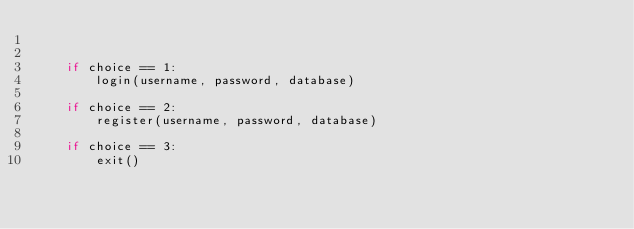<code> <loc_0><loc_0><loc_500><loc_500><_Python_>

    if choice == 1:
        login(username, password, database)
            
    if choice == 2:
        register(username, password, database)
    
    if choice == 3:
        exit()
</code> 